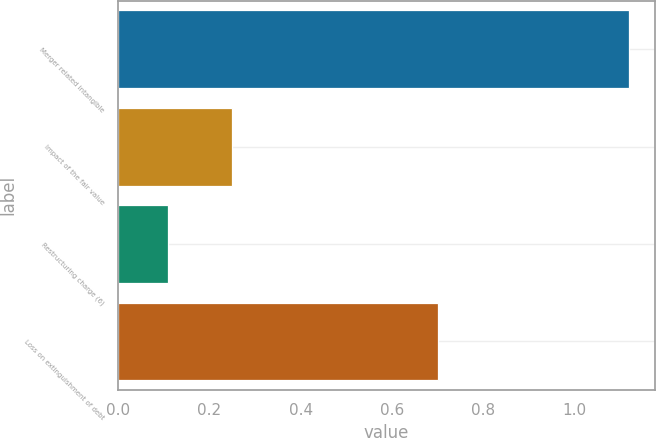<chart> <loc_0><loc_0><loc_500><loc_500><bar_chart><fcel>Merger related intangible<fcel>Impact of the fair value<fcel>Restructuring charge (6)<fcel>Loss on extinguishment of debt<nl><fcel>1.12<fcel>0.25<fcel>0.11<fcel>0.7<nl></chart> 